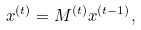Convert formula to latex. <formula><loc_0><loc_0><loc_500><loc_500>x ^ { ( t ) } = M ^ { ( t ) } x ^ { ( t - 1 ) } ,</formula> 